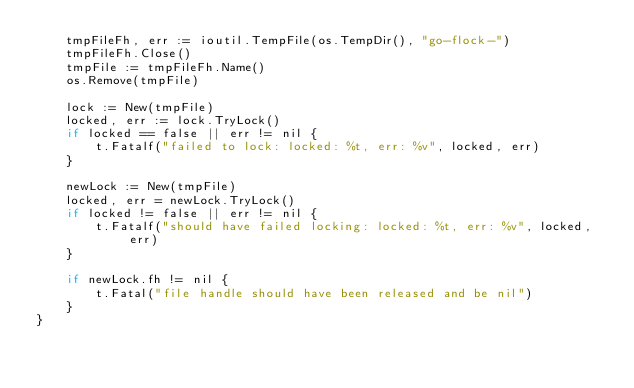<code> <loc_0><loc_0><loc_500><loc_500><_Go_>	tmpFileFh, err := ioutil.TempFile(os.TempDir(), "go-flock-")
	tmpFileFh.Close()
	tmpFile := tmpFileFh.Name()
	os.Remove(tmpFile)

	lock := New(tmpFile)
	locked, err := lock.TryLock()
	if locked == false || err != nil {
		t.Fatalf("failed to lock: locked: %t, err: %v", locked, err)
	}

	newLock := New(tmpFile)
	locked, err = newLock.TryLock()
	if locked != false || err != nil {
		t.Fatalf("should have failed locking: locked: %t, err: %v", locked, err)
	}

	if newLock.fh != nil {
		t.Fatal("file handle should have been released and be nil")
	}
}
</code> 